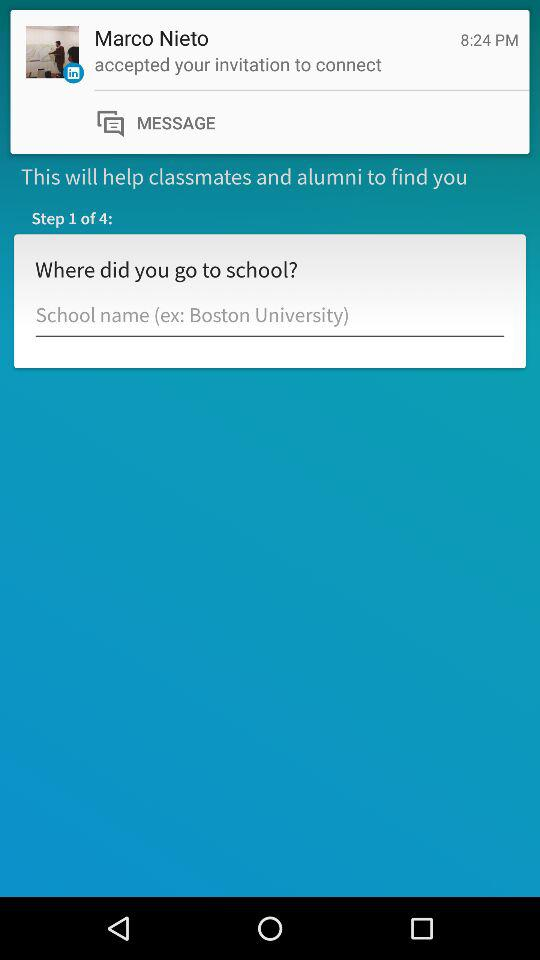At which step am I? You are at the first step. 